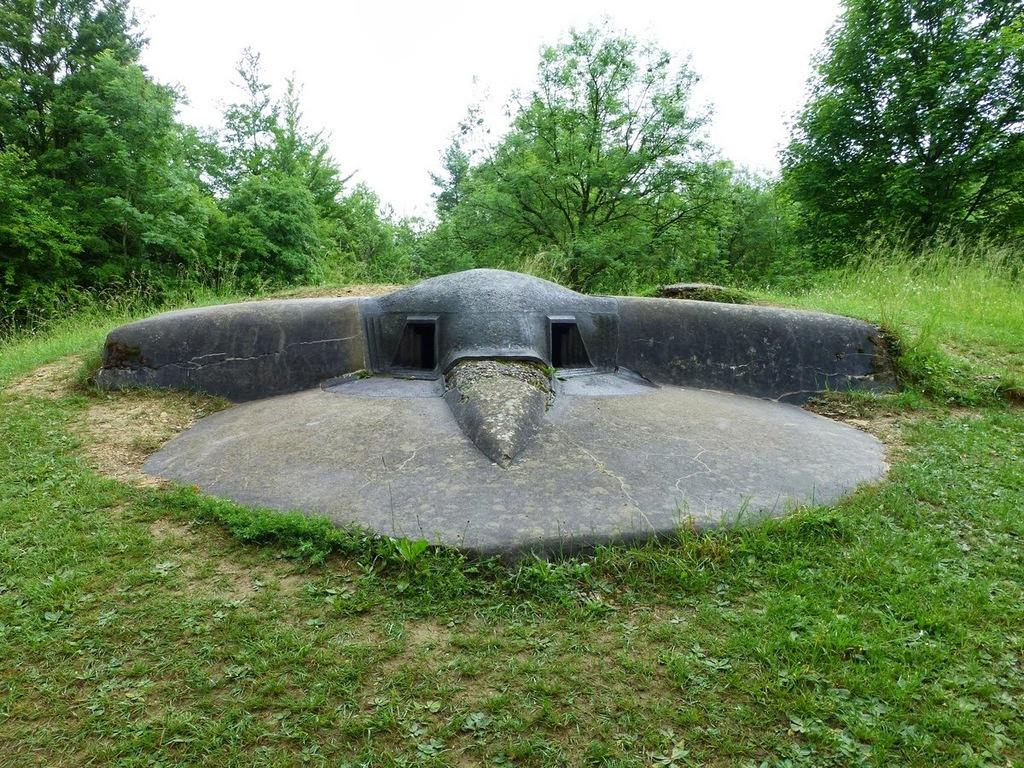What is the location of the house in the image? The house appears to be underground in the image. What type of vegetation can be seen in the image? There is grass, trees, and plants in the image. Which direction is the foot pointing in the image? There is no foot present in the image. 